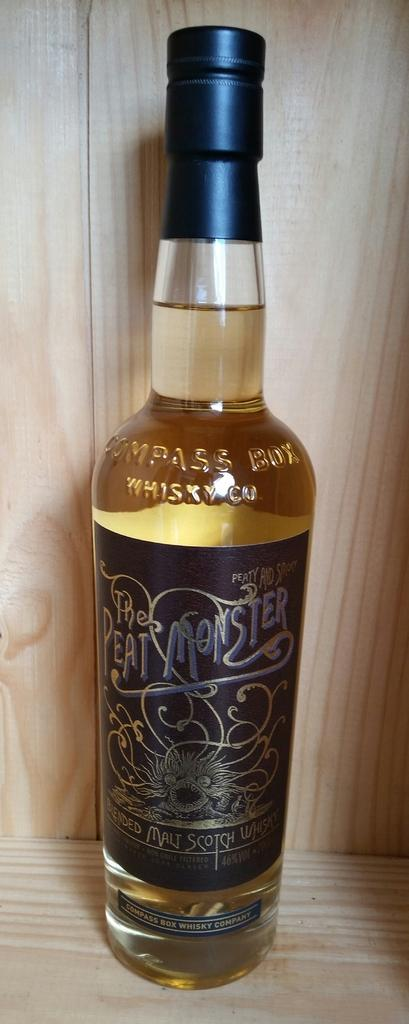<image>
Offer a succinct explanation of the picture presented. A bottle has the brand The Peat Monster on the label. 